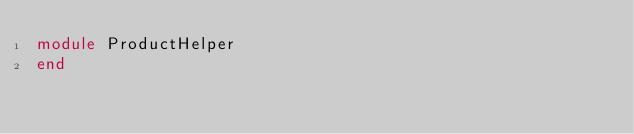Convert code to text. <code><loc_0><loc_0><loc_500><loc_500><_Ruby_>module ProductHelper
end
</code> 